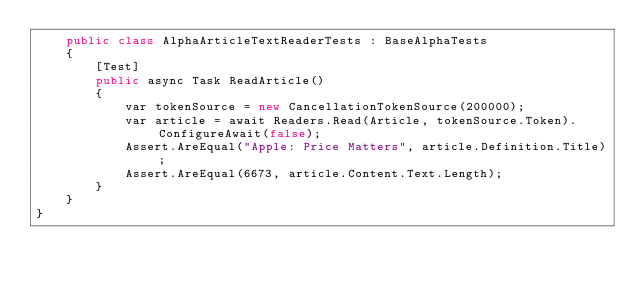Convert code to text. <code><loc_0><loc_0><loc_500><loc_500><_C#_>    public class AlphaArticleTextReaderTests : BaseAlphaTests
    {
        [Test]
        public async Task ReadArticle()
        {
            var tokenSource = new CancellationTokenSource(200000);
            var article = await Readers.Read(Article, tokenSource.Token).ConfigureAwait(false);
            Assert.AreEqual("Apple: Price Matters", article.Definition.Title);
            Assert.AreEqual(6673, article.Content.Text.Length);
        }
    }
}
 </code> 